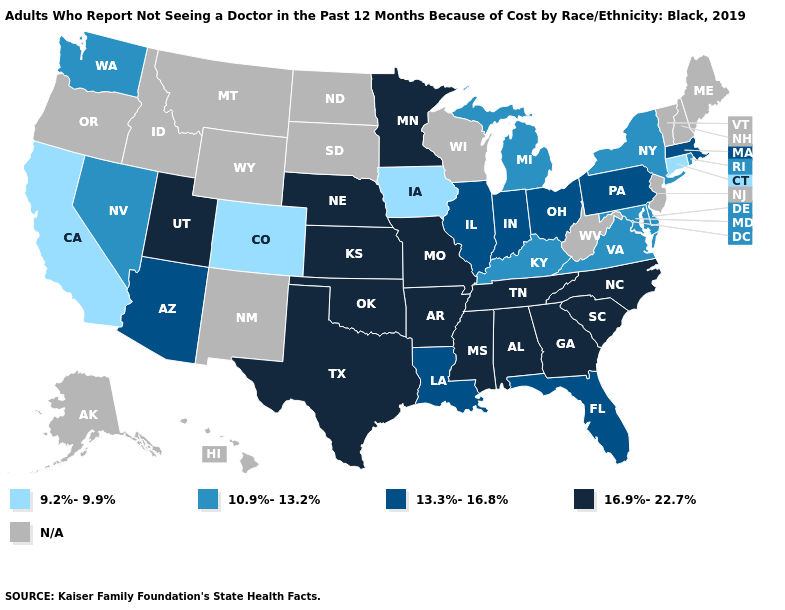Name the states that have a value in the range 9.2%-9.9%?
Keep it brief. California, Colorado, Connecticut, Iowa. Does Arizona have the lowest value in the West?
Write a very short answer. No. Among the states that border Alabama , which have the lowest value?
Concise answer only. Florida. Among the states that border North Carolina , which have the lowest value?
Short answer required. Virginia. How many symbols are there in the legend?
Answer briefly. 5. Which states have the lowest value in the West?
Concise answer only. California, Colorado. What is the highest value in the West ?
Give a very brief answer. 16.9%-22.7%. Is the legend a continuous bar?
Short answer required. No. Name the states that have a value in the range 13.3%-16.8%?
Short answer required. Arizona, Florida, Illinois, Indiana, Louisiana, Massachusetts, Ohio, Pennsylvania. Name the states that have a value in the range N/A?
Keep it brief. Alaska, Hawaii, Idaho, Maine, Montana, New Hampshire, New Jersey, New Mexico, North Dakota, Oregon, South Dakota, Vermont, West Virginia, Wisconsin, Wyoming. What is the highest value in the USA?
Short answer required. 16.9%-22.7%. What is the lowest value in states that border Utah?
Write a very short answer. 9.2%-9.9%. 